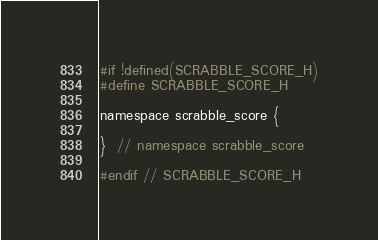<code> <loc_0><loc_0><loc_500><loc_500><_C_>#if !defined(SCRABBLE_SCORE_H)
#define SCRABBLE_SCORE_H

namespace scrabble_score {

}  // namespace scrabble_score

#endif // SCRABBLE_SCORE_H</code> 